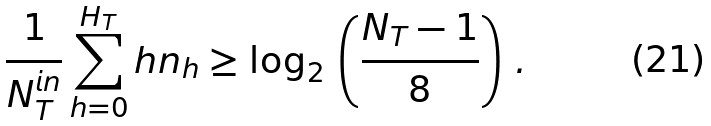Convert formula to latex. <formula><loc_0><loc_0><loc_500><loc_500>\frac { 1 } { N _ { T } ^ { i n } } \sum _ { h = 0 } ^ { H _ { T } } h n _ { h } \geq \log _ { 2 } \, \left ( \frac { N _ { T } - 1 } { 8 } \right ) \, .</formula> 